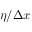Convert formula to latex. <formula><loc_0><loc_0><loc_500><loc_500>\eta / \Delta x</formula> 